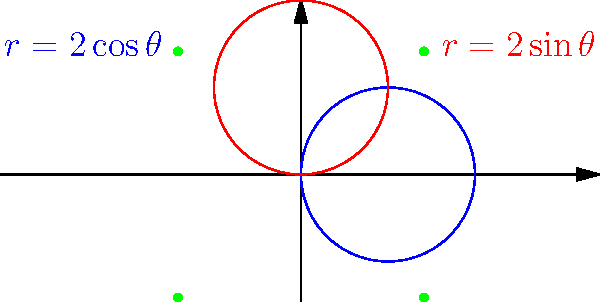As a student-athlete who values precision and analysis, consider the polar curves $r=2\cos\theta$ and $r=2\sin\theta$. How many intersection points do these curves have, and what are their coordinates? Let's approach this step-by-step:

1) To find the intersection points, we need to solve the equation:
   $2\cos\theta = 2\sin\theta$

2) Dividing both sides by 2:
   $\cos\theta = \sin\theta$

3) This is equivalent to:
   $\tan\theta = 1$

4) The solutions to this equation are:
   $\theta = \frac{\pi}{4}, \frac{5\pi}{4}, \frac{3\pi}{4}, \frac{7\pi}{4}$

5) Now, let's find the r-coordinate for each of these θ values:
   For $\theta = \frac{\pi}{4}$ or $\frac{5\pi}{4}$: 
   $r = 2\cos(\frac{\pi}{4}) = 2\sin(\frac{\pi}{4}) = \sqrt{2}$

   For $\theta = \frac{3\pi}{4}$ or $\frac{7\pi}{4}$:
   $r = 2\cos(\frac{3\pi}{4}) = 2\sin(\frac{3\pi}{4}) = -\sqrt{2}$

6) Converting to Cartesian coordinates:
   $(\sqrt{2}, \sqrt{2})$, $(-\sqrt{2}, -\sqrt{2})$, $(-\sqrt{2}, \sqrt{2})$, $(\sqrt{2}, -\sqrt{2})$

Therefore, there are 4 intersection points with the coordinates listed above.
Answer: 4 points: $(\sqrt{2}, \sqrt{2})$, $(-\sqrt{2}, -\sqrt{2})$, $(-\sqrt{2}, \sqrt{2})$, $(\sqrt{2}, -\sqrt{2})$ 